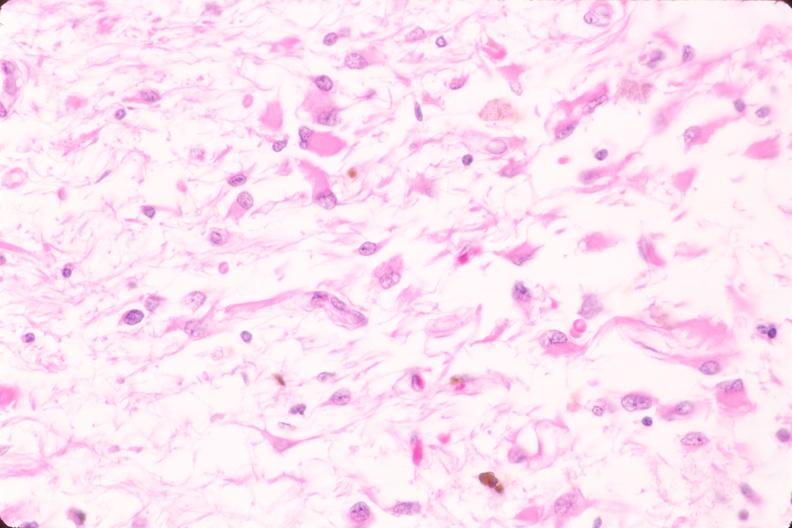what does this image show?
Answer the question using a single word or phrase. Brain 